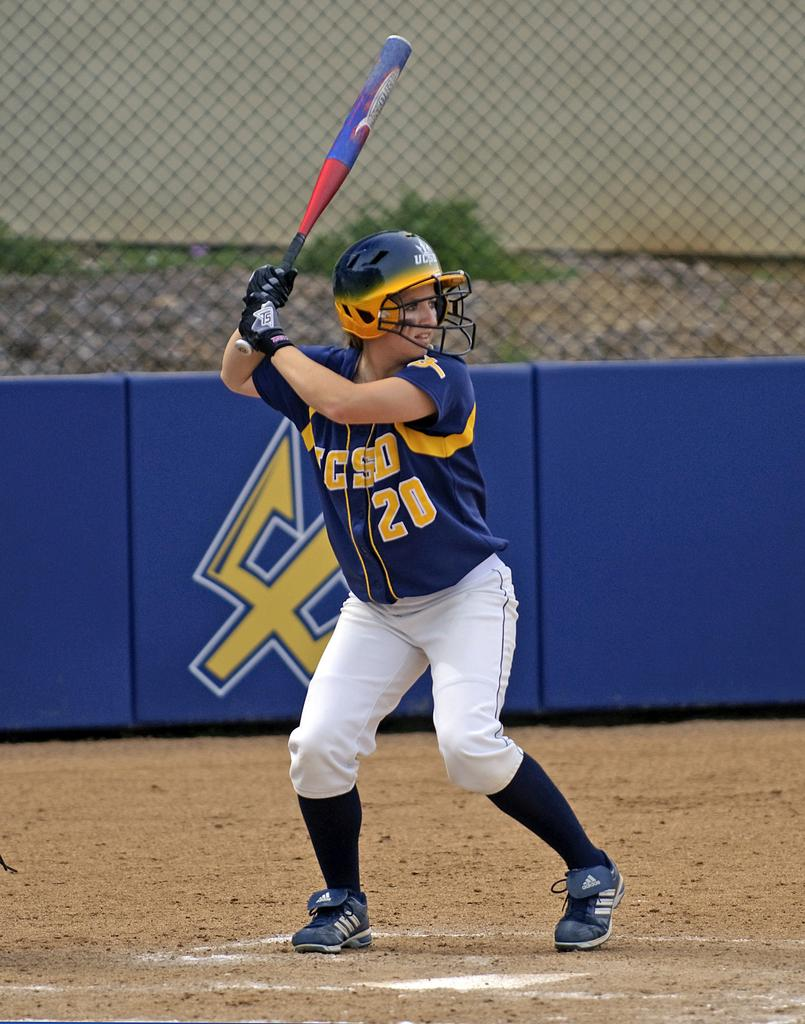Who is present in the image? There is a girl in the image. What is the girl doing in the image? The girl is playing with a baseball bat. Where is the girl located in the image? The girl is in a playground. What can be seen in the background of the image? There is a fencing with a net in the image. What type of crown is the girl wearing in the image? There is no crown present in the image; the girl is playing with a baseball bat. What is the sound of the girl's laughter in the image? There is no sound or indication of laughter in the image; it is a still photograph. 